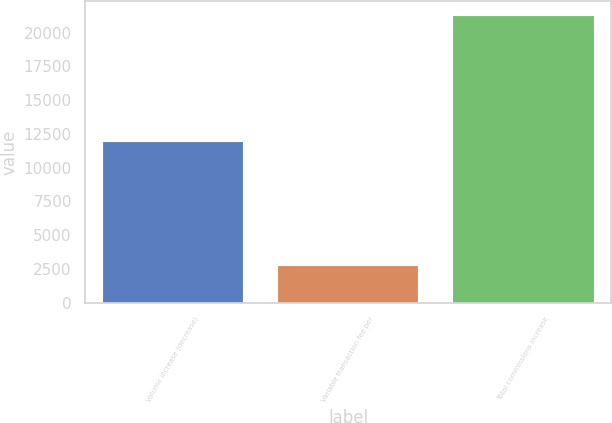Convert chart to OTSL. <chart><loc_0><loc_0><loc_500><loc_500><bar_chart><fcel>Volume increase (decrease)<fcel>Variable transaction fee per<fcel>Total commissions increase<nl><fcel>11865<fcel>2738<fcel>21239<nl></chart> 